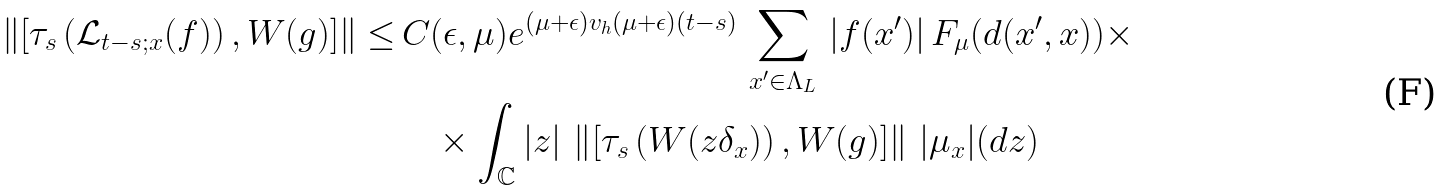<formula> <loc_0><loc_0><loc_500><loc_500>\left \| \left [ \tau _ { s } \left ( \mathcal { L } _ { t - s ; x } ( f ) \right ) , W ( g ) \right ] \right \| \leq & \, C ( \epsilon , \mu ) e ^ { ( \mu + \epsilon ) v _ { h } ( \mu + \epsilon ) ( t - s ) } \, \sum _ { x ^ { \prime } \in \Lambda _ { L } } \, | f ( x ^ { \prime } ) | \, F _ { \mu } ( d ( x ^ { \prime } , x ) ) \times \\ & \quad \times \int _ { \mathbb { C } } | z | \, \left \| \left [ \tau _ { s } \left ( W ( z \delta _ { x } ) \right ) , W ( g ) \right ] \right \| \, | \mu _ { x } | ( d z )</formula> 